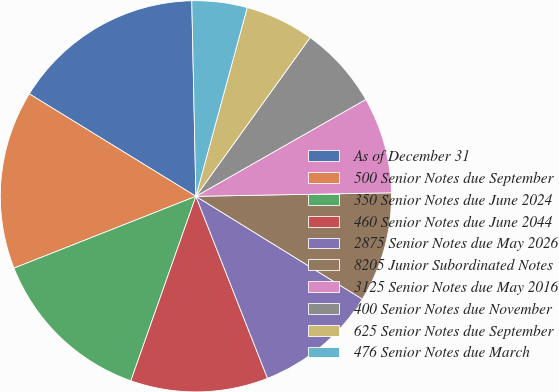<chart> <loc_0><loc_0><loc_500><loc_500><pie_chart><fcel>As of December 31<fcel>500 Senior Notes due September<fcel>350 Senior Notes due June 2024<fcel>460 Senior Notes due June 2044<fcel>2875 Senior Notes due May 2026<fcel>8205 Junior Subordinated Notes<fcel>3125 Senior Notes due May 2016<fcel>400 Senior Notes due November<fcel>625 Senior Notes due September<fcel>476 Senior Notes due March<nl><fcel>15.89%<fcel>14.76%<fcel>13.62%<fcel>11.36%<fcel>10.23%<fcel>9.09%<fcel>7.96%<fcel>6.83%<fcel>5.7%<fcel>4.56%<nl></chart> 